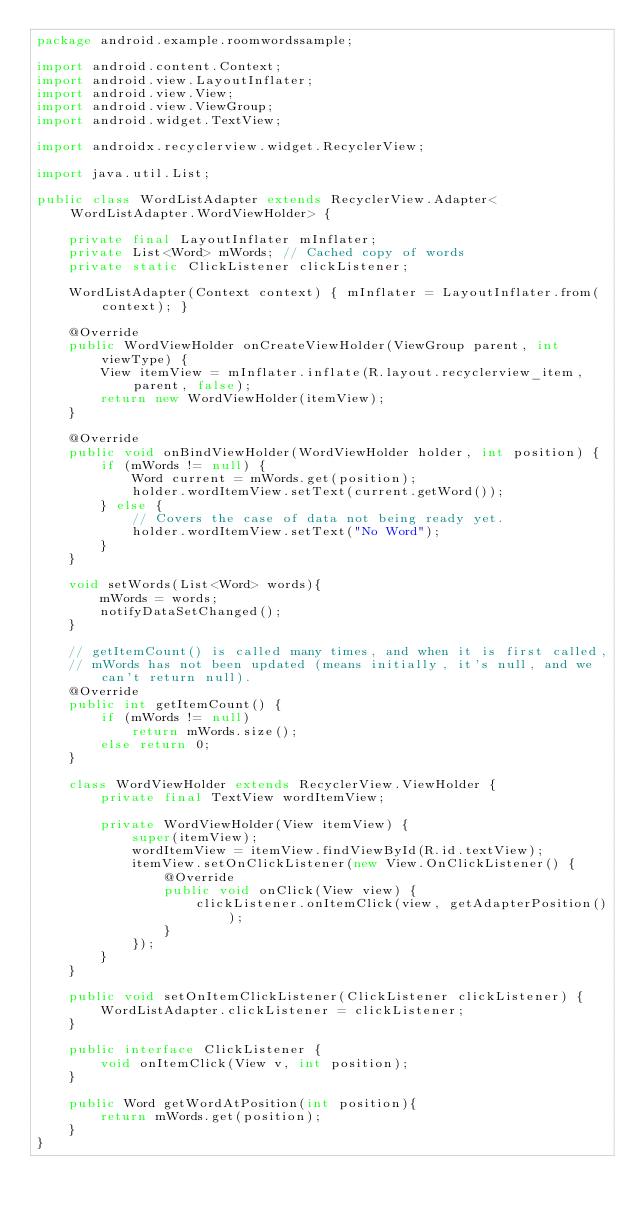Convert code to text. <code><loc_0><loc_0><loc_500><loc_500><_Java_>package android.example.roomwordssample;

import android.content.Context;
import android.view.LayoutInflater;
import android.view.View;
import android.view.ViewGroup;
import android.widget.TextView;

import androidx.recyclerview.widget.RecyclerView;

import java.util.List;

public class WordListAdapter extends RecyclerView.Adapter<WordListAdapter.WordViewHolder> {

    private final LayoutInflater mInflater;
    private List<Word> mWords; // Cached copy of words
    private static ClickListener clickListener;

    WordListAdapter(Context context) { mInflater = LayoutInflater.from(context); }

    @Override
    public WordViewHolder onCreateViewHolder(ViewGroup parent, int viewType) {
        View itemView = mInflater.inflate(R.layout.recyclerview_item, parent, false);
        return new WordViewHolder(itemView);
    }

    @Override
    public void onBindViewHolder(WordViewHolder holder, int position) {
        if (mWords != null) {
            Word current = mWords.get(position);
            holder.wordItemView.setText(current.getWord());
        } else {
            // Covers the case of data not being ready yet.
            holder.wordItemView.setText("No Word");
        }
    }

    void setWords(List<Word> words){
        mWords = words;
        notifyDataSetChanged();
    }

    // getItemCount() is called many times, and when it is first called,
    // mWords has not been updated (means initially, it's null, and we can't return null).
    @Override
    public int getItemCount() {
        if (mWords != null)
            return mWords.size();
        else return 0;
    }

    class WordViewHolder extends RecyclerView.ViewHolder {
        private final TextView wordItemView;

        private WordViewHolder(View itemView) {
            super(itemView);
            wordItemView = itemView.findViewById(R.id.textView);
            itemView.setOnClickListener(new View.OnClickListener() {
                @Override
                public void onClick(View view) {
                    clickListener.onItemClick(view, getAdapterPosition());
                }
            });
        }
    }

    public void setOnItemClickListener(ClickListener clickListener) {
        WordListAdapter.clickListener = clickListener;
    }

    public interface ClickListener {
        void onItemClick(View v, int position);
    }

    public Word getWordAtPosition(int position){
        return mWords.get(position);
    }
}
</code> 